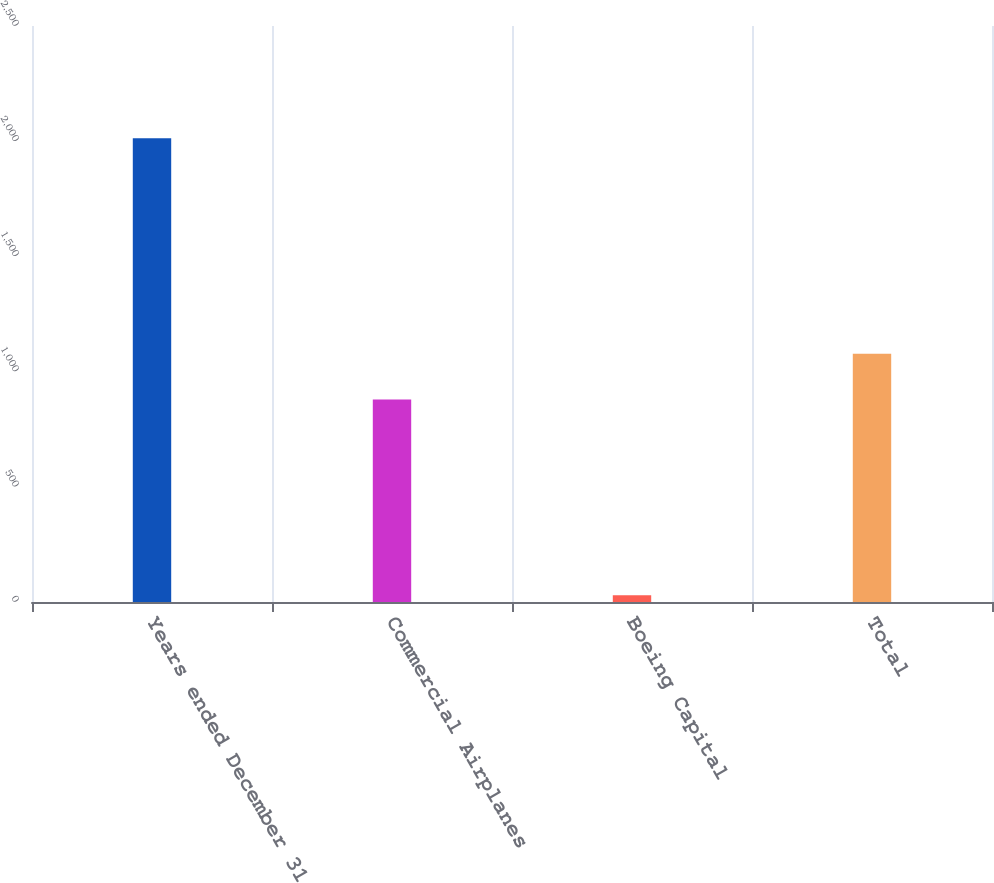Convert chart to OTSL. <chart><loc_0><loc_0><loc_500><loc_500><bar_chart><fcel>Years ended December 31<fcel>Commercial Airplanes<fcel>Boeing Capital<fcel>Total<nl><fcel>2013<fcel>879<fcel>29<fcel>1077.4<nl></chart> 